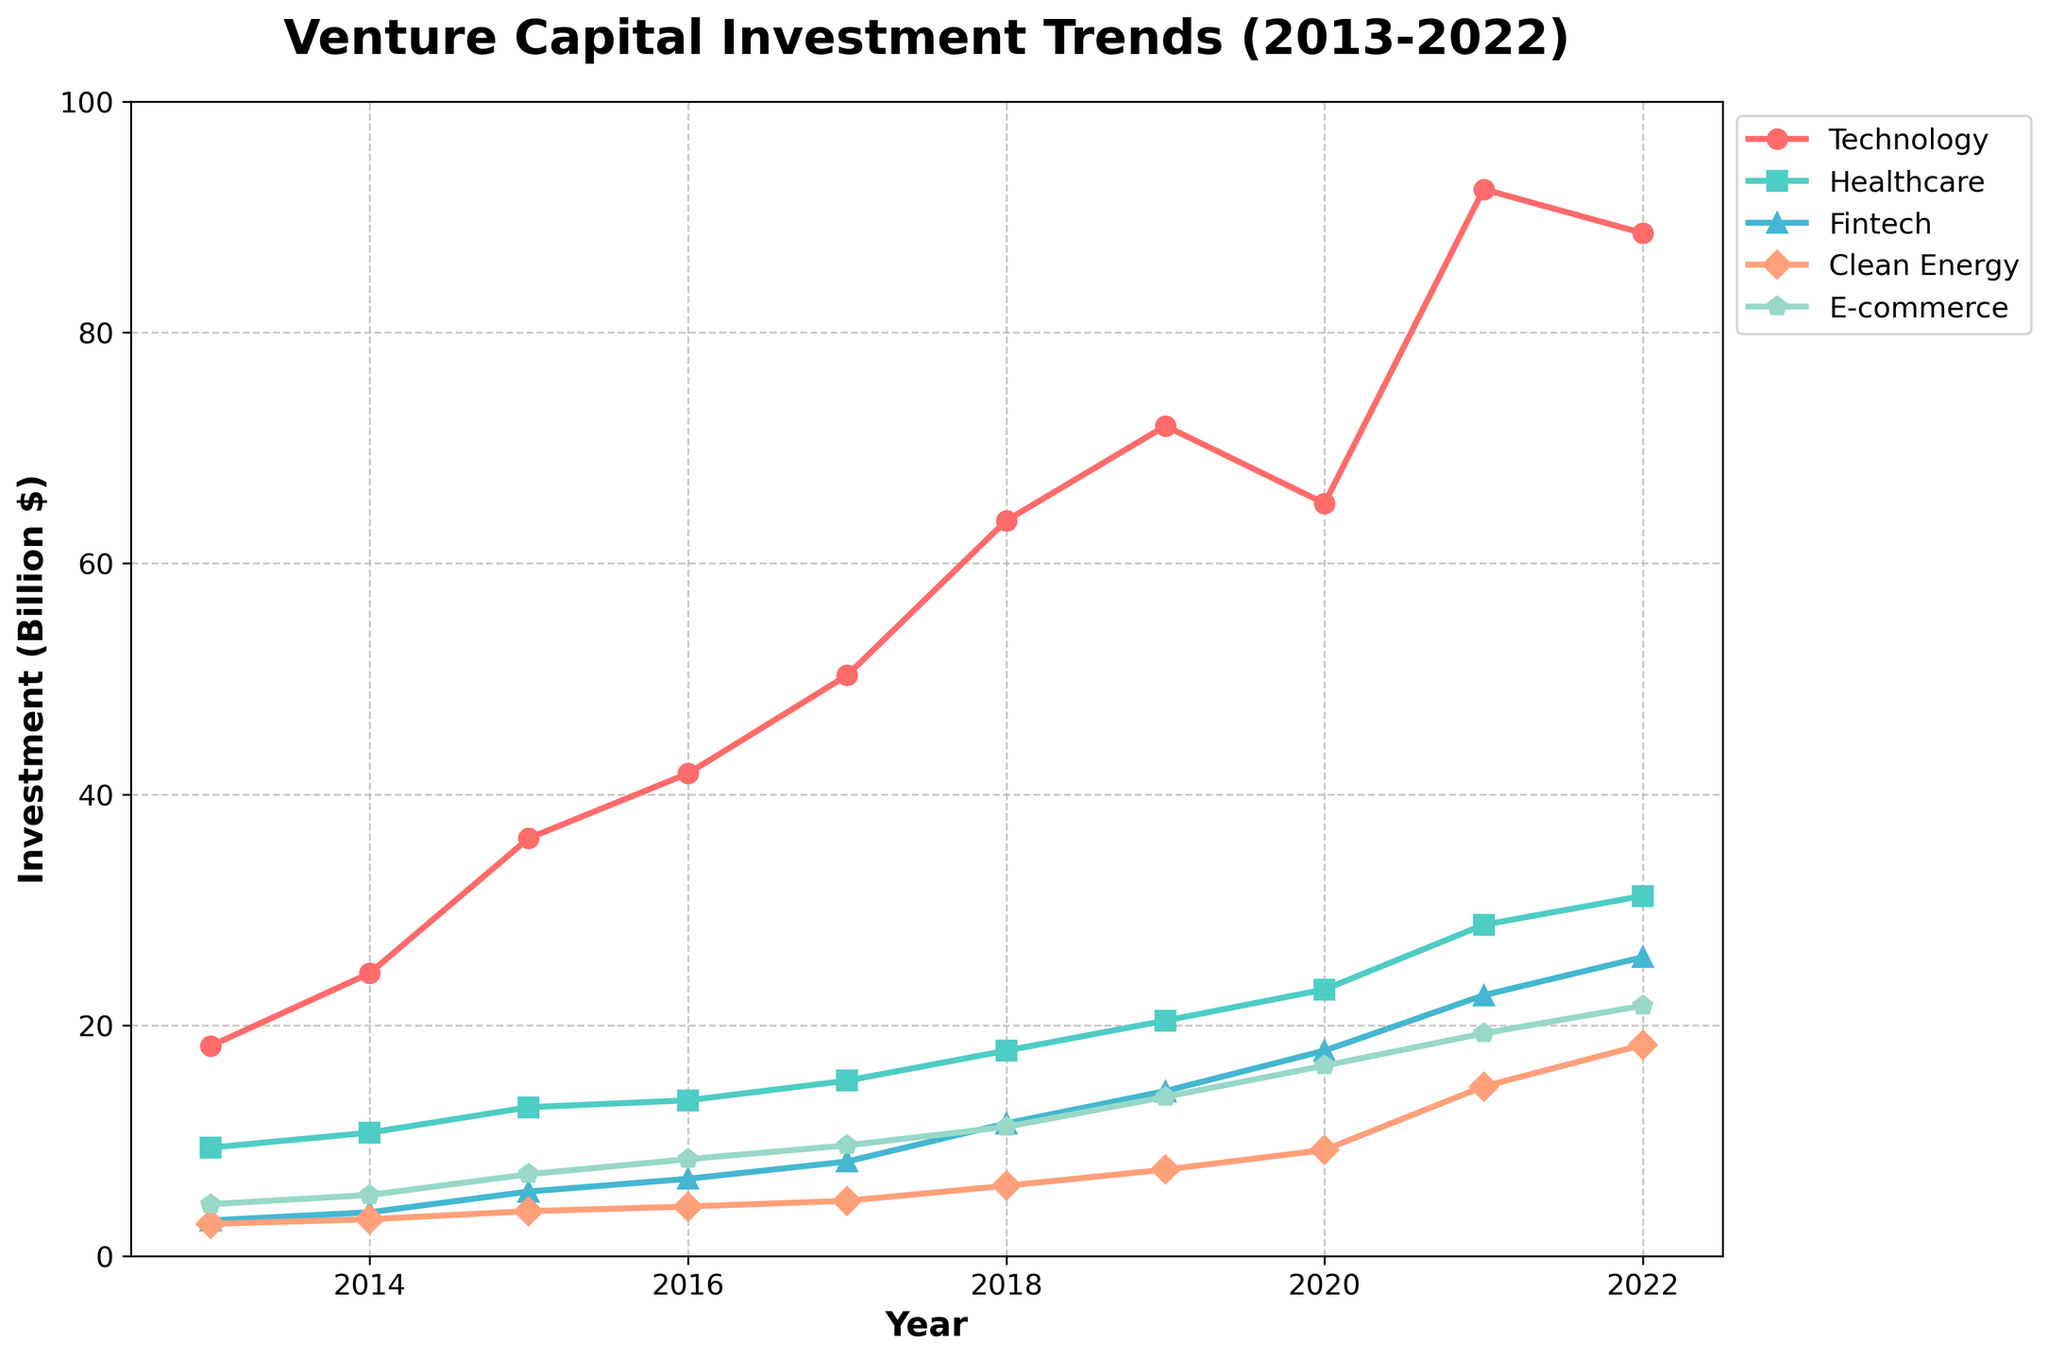Which industry experienced the highest venture capital investment in 2022? Look at the data points for each industry in 2022 and identify the highest value. The 'Technology' sector has the highest investment of 88.6 billion dollars in 2022.
Answer: Technology What was the percentage increase in venture capital investment for the Healthcare industry from 2013 to 2022? Calculate the initial and final values for the Healthcare industry and use the percentage increase formula: \((\frac{31.2 - 9.4}{9.4}) \times 100\% \). This results in \((\frac{31.2 - 9.4}{9.4}) \times 100\% = 231.9\%\).
Answer: 231.9% How much more venture capital was invested in Fintech in 2022 compared to 2013? Look at the investment values for Fintech in 2022 and 2013, then calculate the difference: 25.9 - 3.1 = 22.8 billion dollars.
Answer: 22.8 billion dollars Which year saw the largest investment increase in the Technology sector compared to the previous year? Calculate the year-over-year differences for Technology and find the maximum increase: from 2014 to 2015: (36.2 - 24.5) = 11.7, from 2015 to 2016: (41.8 - 36.2) = 5.6, etc. The largest increase is from 2017 to 2018: (63.7 - 50.3) = 13.4.
Answer: 2018 In which years did the Clean Energy sector see its investments double compared to 2013? Calculate double the 2013 value of Clean Energy (2.8 \(\times\) 2 = 5.6) and check which years had investments higher or equal to 5.6 billion dollars. The years 2018, 2019, 2020, 2021, and 2022 all meet this criterion.
Answer: 2018, 2019, 2020, 2021, 2022 What is the average annual investment in E-commerce over the decade? Sum the annual investments for E-commerce from 2013 to 2022 and divide by the number of years: \( (\frac{4.5 + 5.3 + 7.1 + 8.4 + 9.6 + 11.2 + 13.8 + 16.5 + 19.3 + 21.7}{10}) = 11.74 \) billion dollars.
Answer: 11.74 billion dollars Which industry saw the smallest total increase from 2013 to 2022? Calculate the total increase for each industry from 2013 to 2022. Technology: 88.6 - 18.2 = 70.4, Healthcare: 31.2 - 9.4 = 21.8, Fintech: 25.9 - 3.1 = 22.8, Clean Energy: 18.3 - 2.8 = 15.5, E-commerce: 21.7 - 4.5 = 17.2. The smallest increase is in Clean Energy with 15.5 billion dollars.
Answer: Clean Energy 